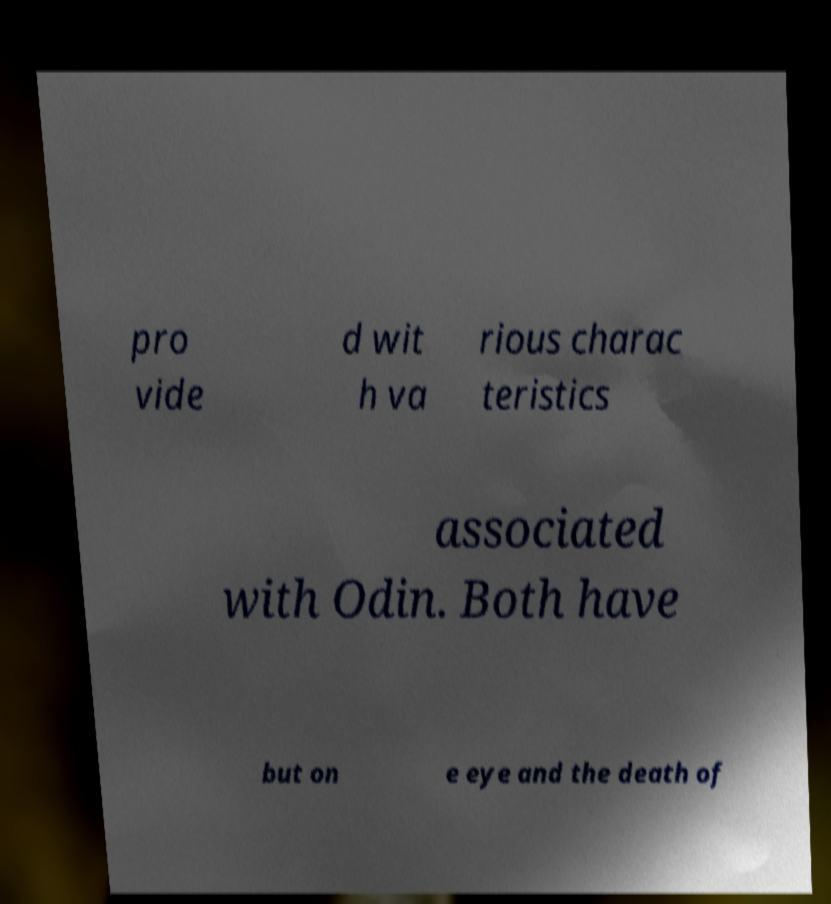Can you accurately transcribe the text from the provided image for me? pro vide d wit h va rious charac teristics associated with Odin. Both have but on e eye and the death of 